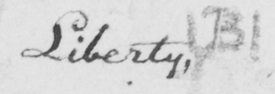What text is written in this handwritten line? Liberty ,  ( B ) 